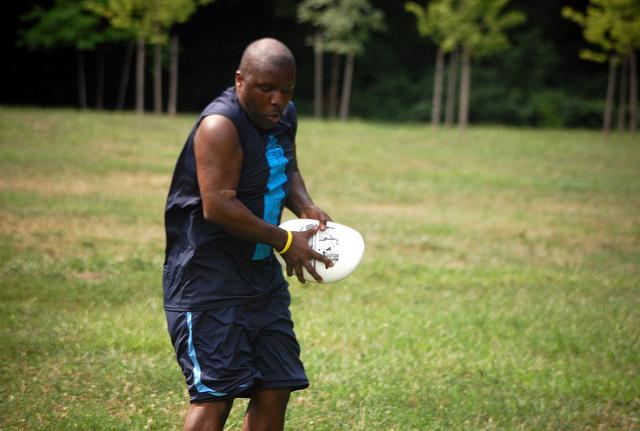Is the man happy?
Concise answer only. Yes. What is on the man's shirt?
Quick response, please. Tower. What is the man doing?
Short answer required. Catching frisbee. What is the man holding?
Answer briefly. Frisbee. Is this a professional athlete?
Keep it brief. No. Was this photo taken inside?
Answer briefly. No. What color is the soccer ball?
Be succinct. White. 